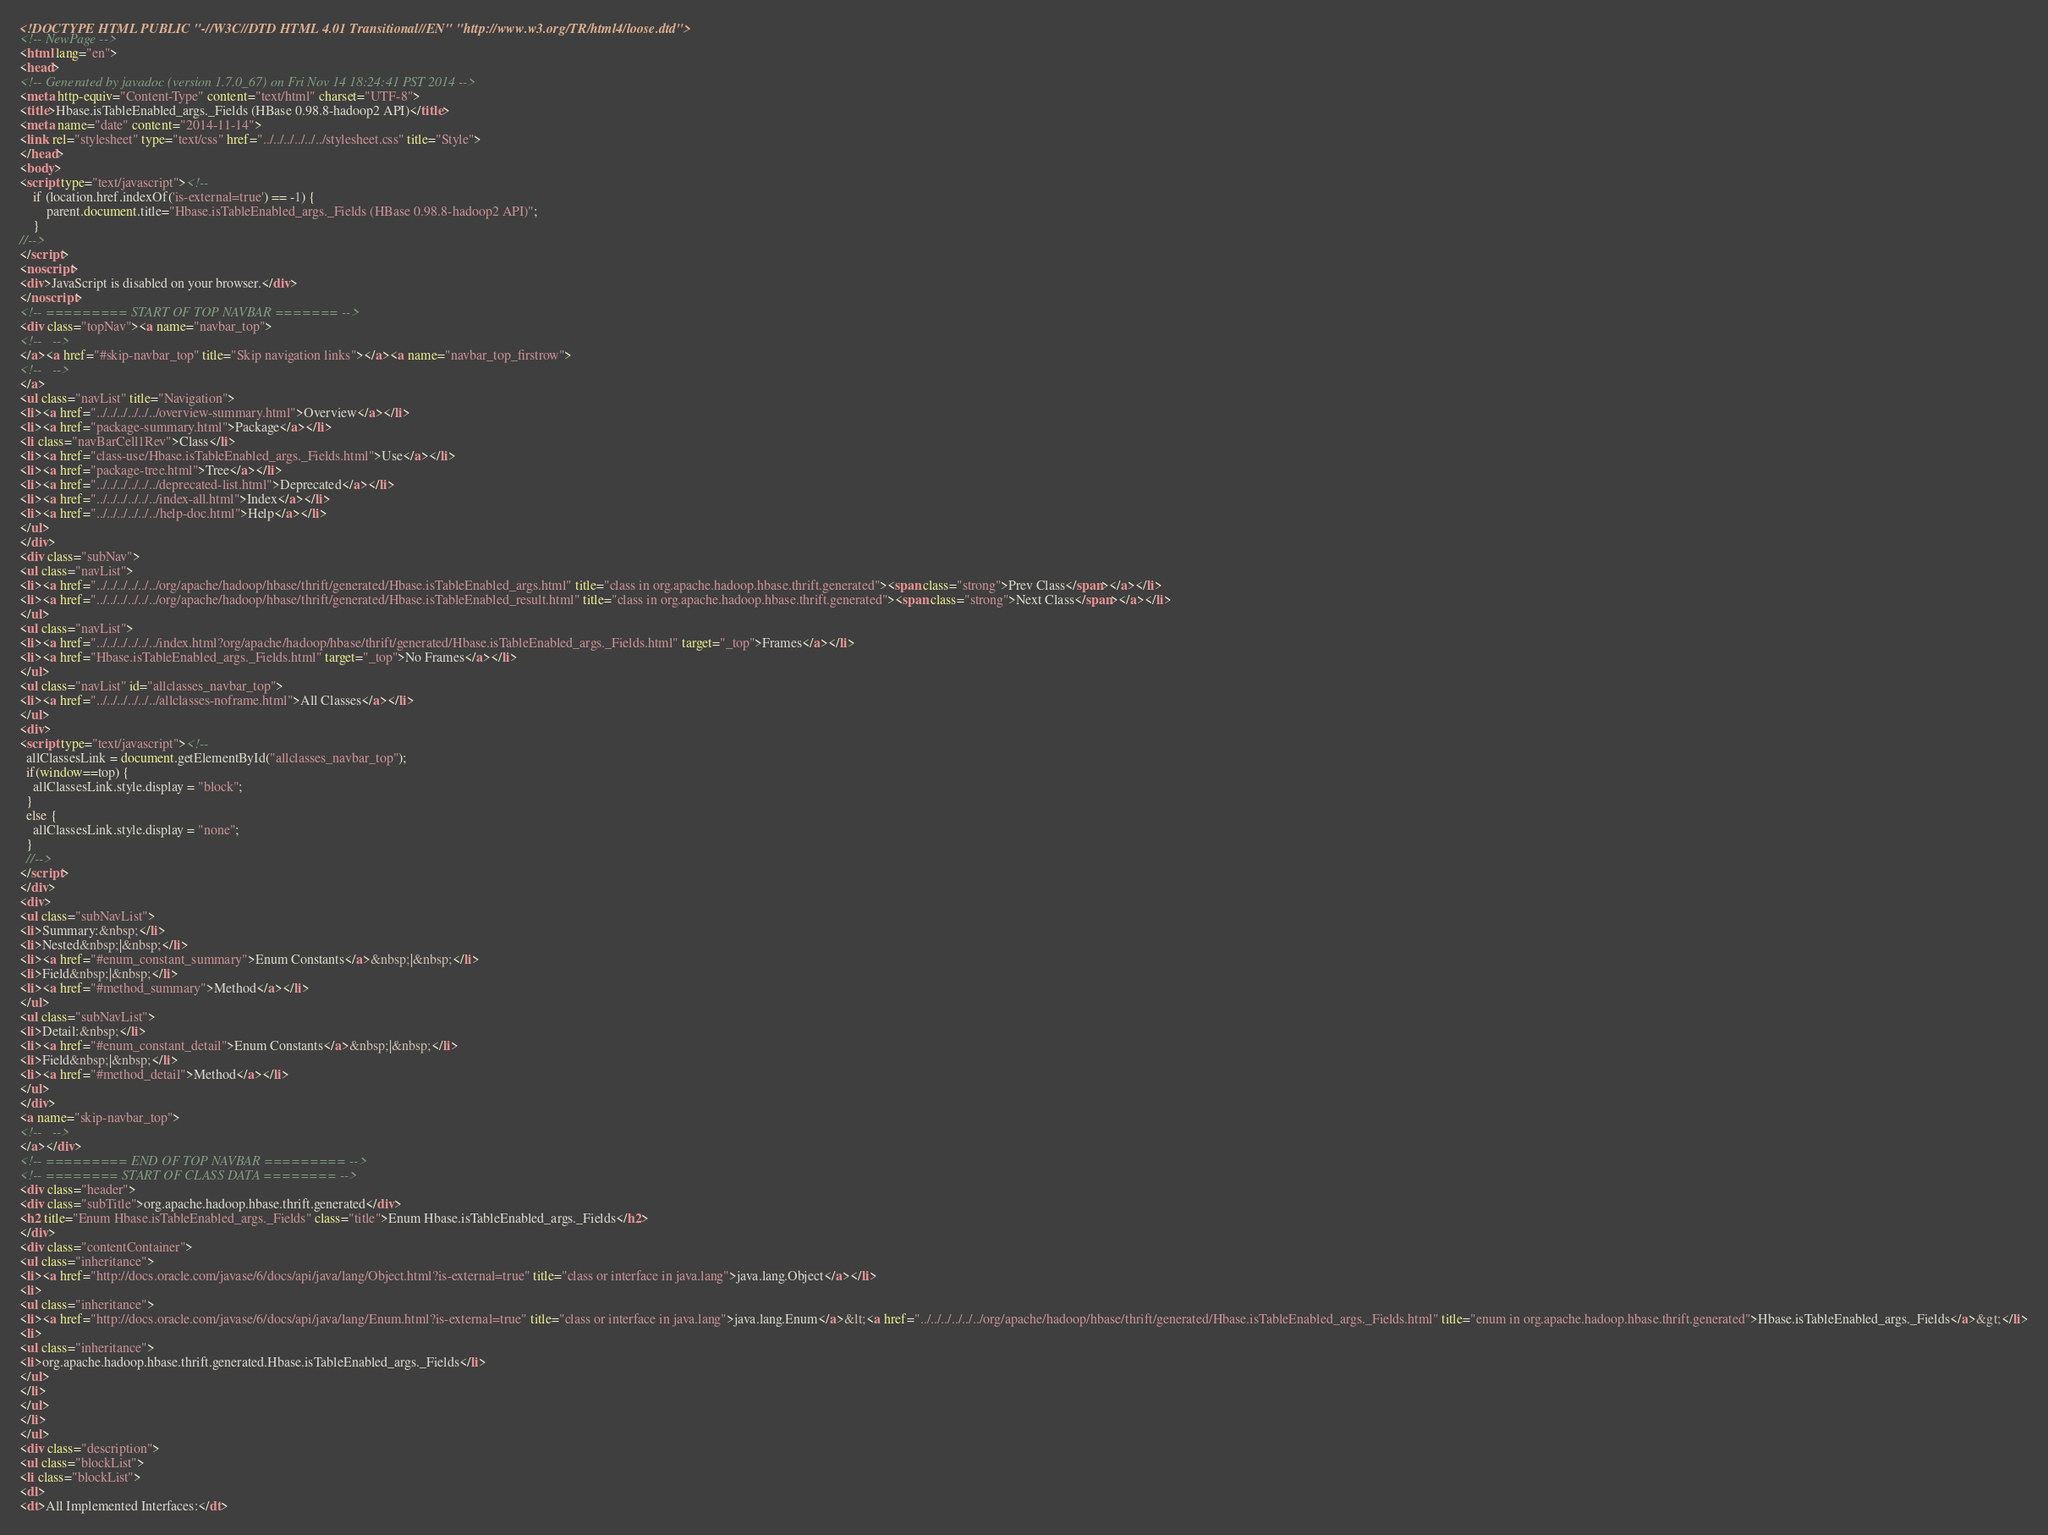<code> <loc_0><loc_0><loc_500><loc_500><_HTML_><!DOCTYPE HTML PUBLIC "-//W3C//DTD HTML 4.01 Transitional//EN" "http://www.w3.org/TR/html4/loose.dtd">
<!-- NewPage -->
<html lang="en">
<head>
<!-- Generated by javadoc (version 1.7.0_67) on Fri Nov 14 18:24:41 PST 2014 -->
<meta http-equiv="Content-Type" content="text/html" charset="UTF-8">
<title>Hbase.isTableEnabled_args._Fields (HBase 0.98.8-hadoop2 API)</title>
<meta name="date" content="2014-11-14">
<link rel="stylesheet" type="text/css" href="../../../../../../stylesheet.css" title="Style">
</head>
<body>
<script type="text/javascript"><!--
    if (location.href.indexOf('is-external=true') == -1) {
        parent.document.title="Hbase.isTableEnabled_args._Fields (HBase 0.98.8-hadoop2 API)";
    }
//-->
</script>
<noscript>
<div>JavaScript is disabled on your browser.</div>
</noscript>
<!-- ========= START OF TOP NAVBAR ======= -->
<div class="topNav"><a name="navbar_top">
<!--   -->
</a><a href="#skip-navbar_top" title="Skip navigation links"></a><a name="navbar_top_firstrow">
<!--   -->
</a>
<ul class="navList" title="Navigation">
<li><a href="../../../../../../overview-summary.html">Overview</a></li>
<li><a href="package-summary.html">Package</a></li>
<li class="navBarCell1Rev">Class</li>
<li><a href="class-use/Hbase.isTableEnabled_args._Fields.html">Use</a></li>
<li><a href="package-tree.html">Tree</a></li>
<li><a href="../../../../../../deprecated-list.html">Deprecated</a></li>
<li><a href="../../../../../../index-all.html">Index</a></li>
<li><a href="../../../../../../help-doc.html">Help</a></li>
</ul>
</div>
<div class="subNav">
<ul class="navList">
<li><a href="../../../../../../org/apache/hadoop/hbase/thrift/generated/Hbase.isTableEnabled_args.html" title="class in org.apache.hadoop.hbase.thrift.generated"><span class="strong">Prev Class</span></a></li>
<li><a href="../../../../../../org/apache/hadoop/hbase/thrift/generated/Hbase.isTableEnabled_result.html" title="class in org.apache.hadoop.hbase.thrift.generated"><span class="strong">Next Class</span></a></li>
</ul>
<ul class="navList">
<li><a href="../../../../../../index.html?org/apache/hadoop/hbase/thrift/generated/Hbase.isTableEnabled_args._Fields.html" target="_top">Frames</a></li>
<li><a href="Hbase.isTableEnabled_args._Fields.html" target="_top">No Frames</a></li>
</ul>
<ul class="navList" id="allclasses_navbar_top">
<li><a href="../../../../../../allclasses-noframe.html">All Classes</a></li>
</ul>
<div>
<script type="text/javascript"><!--
  allClassesLink = document.getElementById("allclasses_navbar_top");
  if(window==top) {
    allClassesLink.style.display = "block";
  }
  else {
    allClassesLink.style.display = "none";
  }
  //-->
</script>
</div>
<div>
<ul class="subNavList">
<li>Summary:&nbsp;</li>
<li>Nested&nbsp;|&nbsp;</li>
<li><a href="#enum_constant_summary">Enum Constants</a>&nbsp;|&nbsp;</li>
<li>Field&nbsp;|&nbsp;</li>
<li><a href="#method_summary">Method</a></li>
</ul>
<ul class="subNavList">
<li>Detail:&nbsp;</li>
<li><a href="#enum_constant_detail">Enum Constants</a>&nbsp;|&nbsp;</li>
<li>Field&nbsp;|&nbsp;</li>
<li><a href="#method_detail">Method</a></li>
</ul>
</div>
<a name="skip-navbar_top">
<!--   -->
</a></div>
<!-- ========= END OF TOP NAVBAR ========= -->
<!-- ======== START OF CLASS DATA ======== -->
<div class="header">
<div class="subTitle">org.apache.hadoop.hbase.thrift.generated</div>
<h2 title="Enum Hbase.isTableEnabled_args._Fields" class="title">Enum Hbase.isTableEnabled_args._Fields</h2>
</div>
<div class="contentContainer">
<ul class="inheritance">
<li><a href="http://docs.oracle.com/javase/6/docs/api/java/lang/Object.html?is-external=true" title="class or interface in java.lang">java.lang.Object</a></li>
<li>
<ul class="inheritance">
<li><a href="http://docs.oracle.com/javase/6/docs/api/java/lang/Enum.html?is-external=true" title="class or interface in java.lang">java.lang.Enum</a>&lt;<a href="../../../../../../org/apache/hadoop/hbase/thrift/generated/Hbase.isTableEnabled_args._Fields.html" title="enum in org.apache.hadoop.hbase.thrift.generated">Hbase.isTableEnabled_args._Fields</a>&gt;</li>
<li>
<ul class="inheritance">
<li>org.apache.hadoop.hbase.thrift.generated.Hbase.isTableEnabled_args._Fields</li>
</ul>
</li>
</ul>
</li>
</ul>
<div class="description">
<ul class="blockList">
<li class="blockList">
<dl>
<dt>All Implemented Interfaces:</dt></code> 